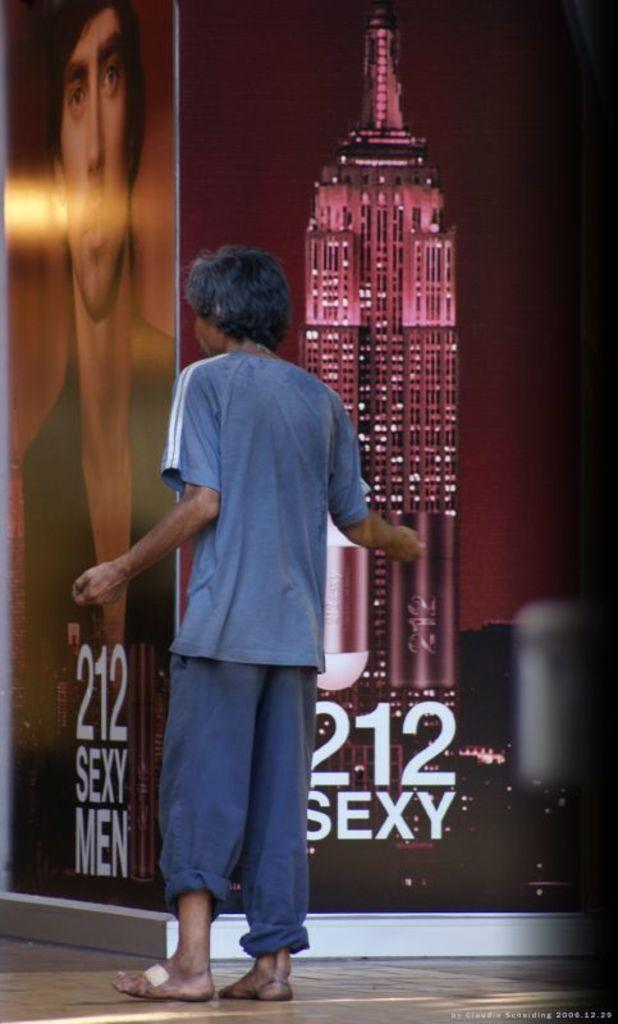Who or what is the main subject in the center of the image? There is a person in the center of the image. What can be seen in the background of the image? There are boards in the background of the image. What is the surface that the person is standing on? There is a floor visible at the bottom of the image. What additional information can be found in the image? There is some text present in the image. What color is the shirt worn by the person in the image? There is no information about the person's shirt in the provided facts, so we cannot determine its color. How much does the hall weigh in the image? There is no hall present in the image, so we cannot determine its weight. 